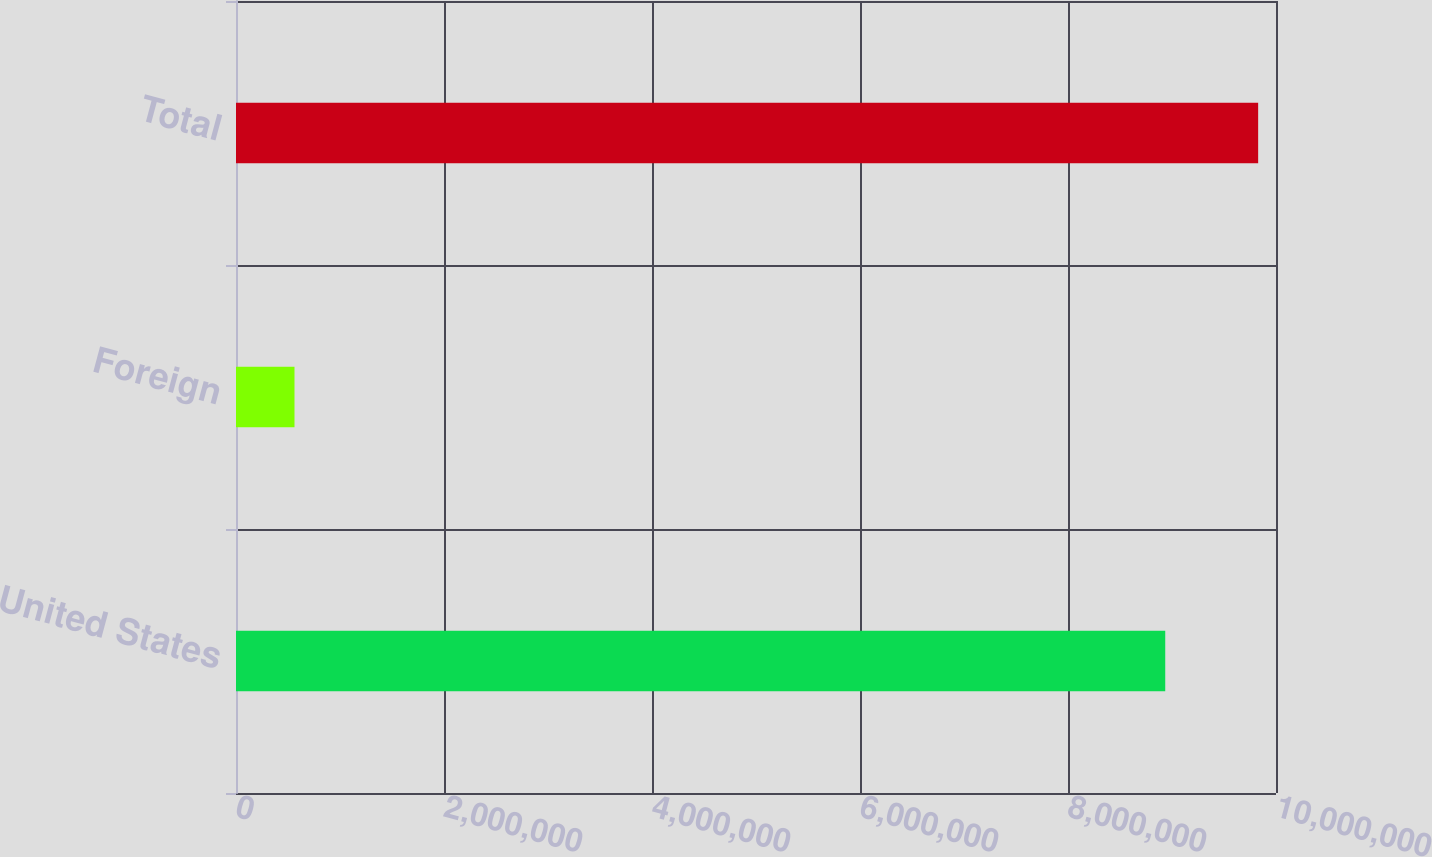Convert chart. <chart><loc_0><loc_0><loc_500><loc_500><bar_chart><fcel>United States<fcel>Foreign<fcel>Total<nl><fcel>8.93491e+06<fcel>562406<fcel>9.8284e+06<nl></chart> 